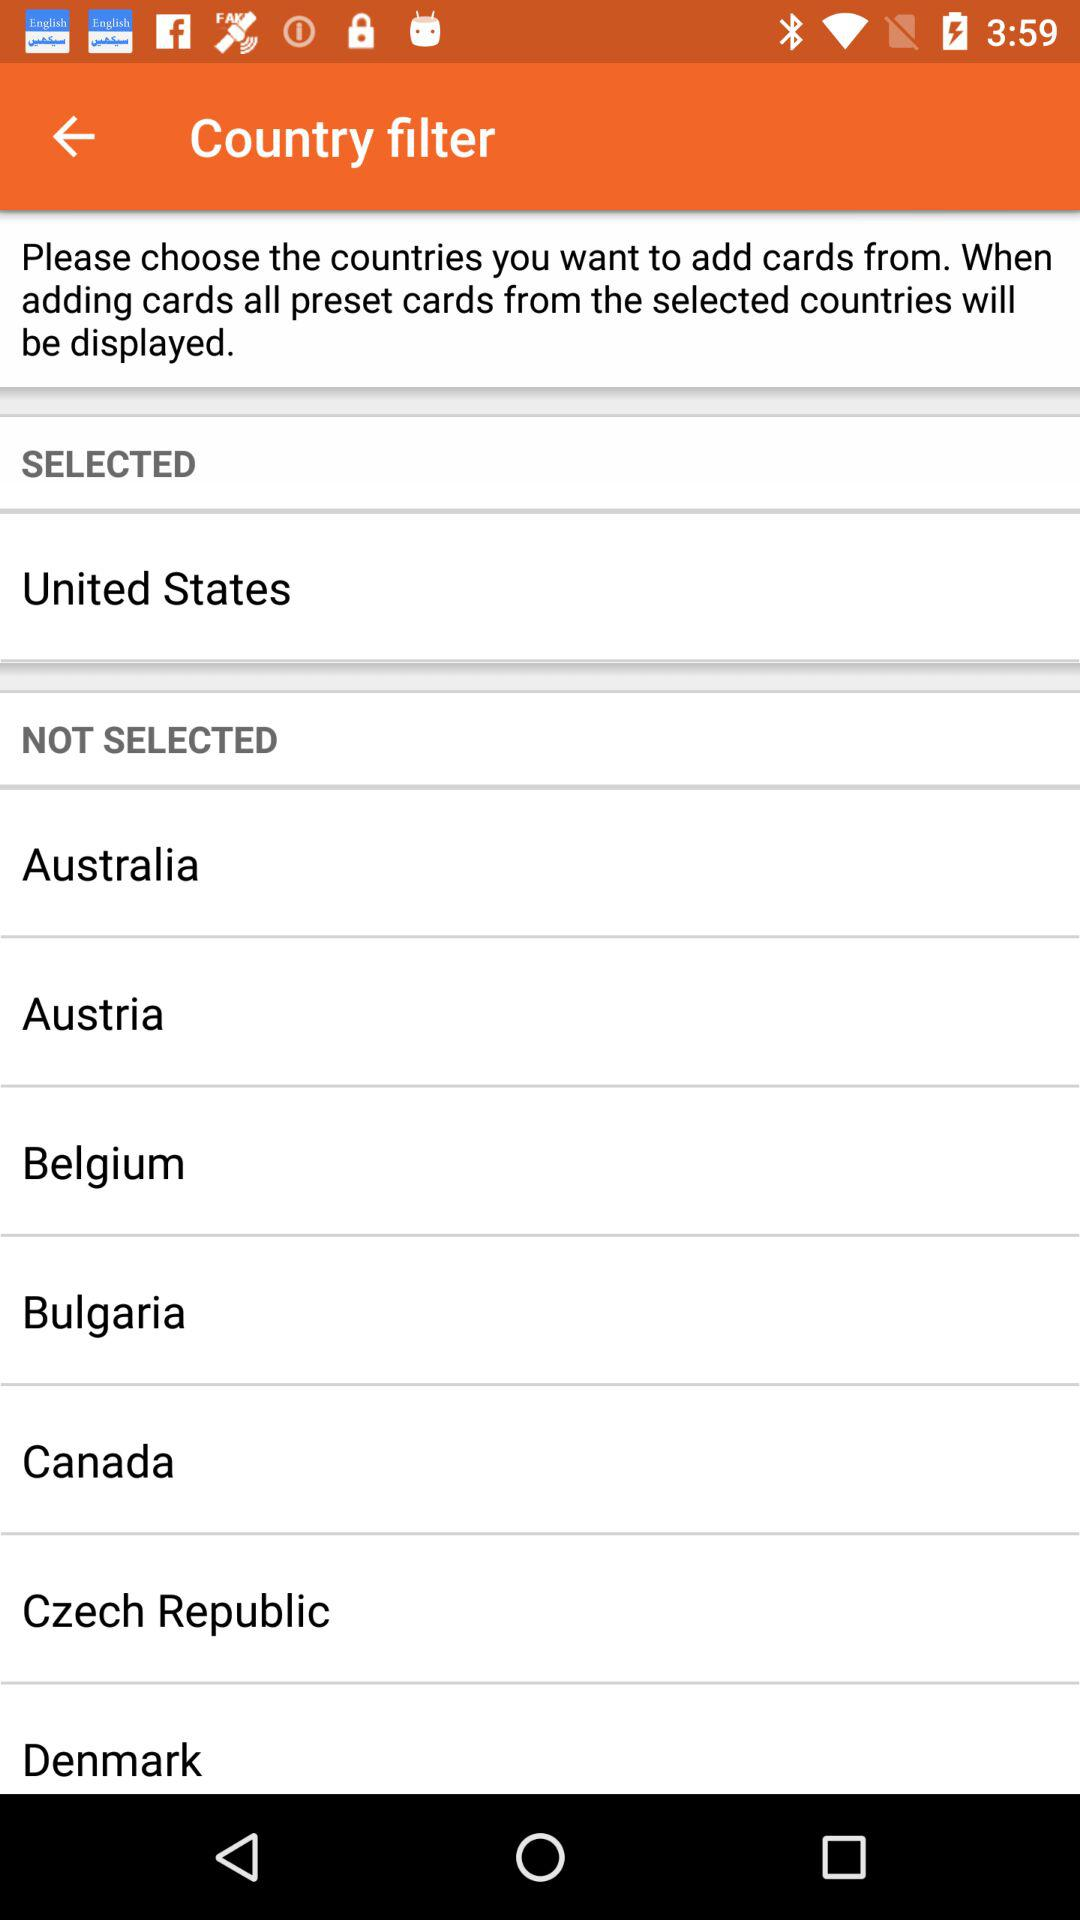What are the names of the countries which are not selected? The names of the countries are Australia, Austria, Belgium, Bulgaria, Canada, the Czech Republic and Denmark. 